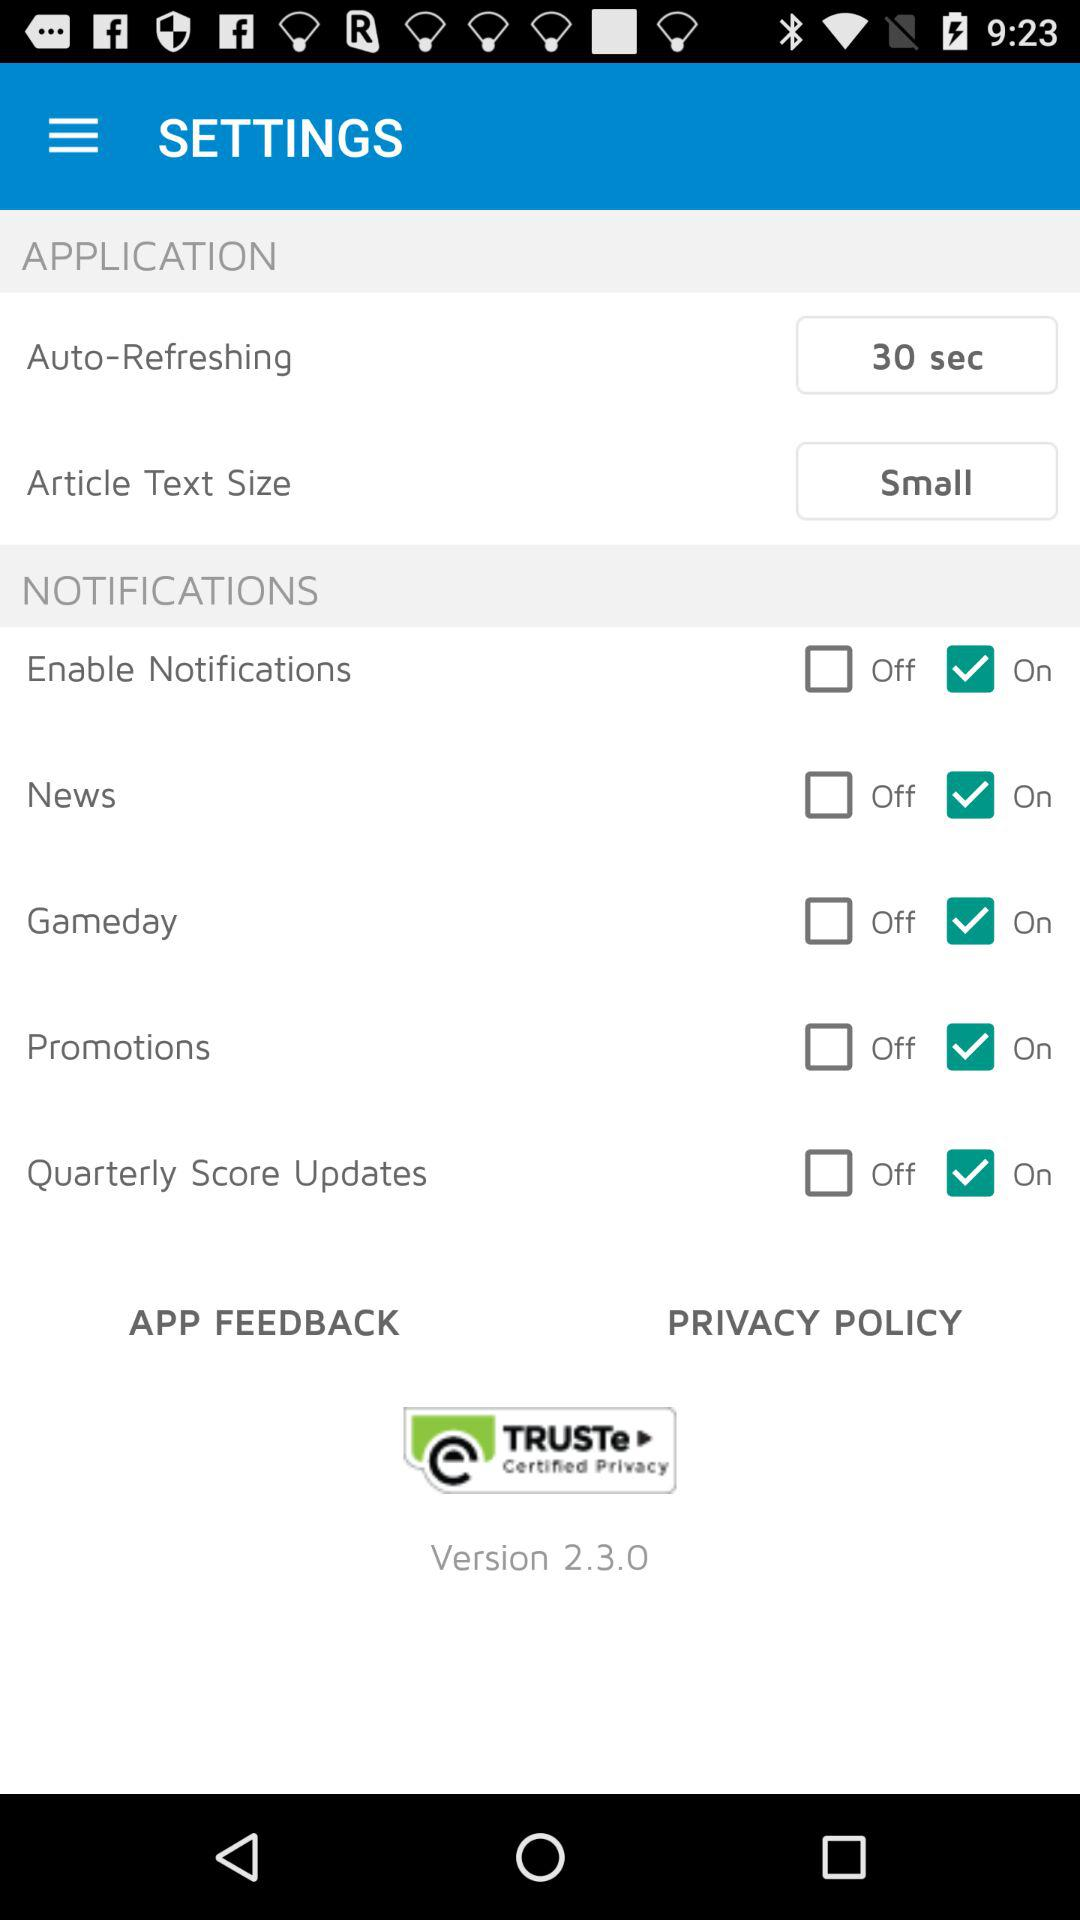What is the current status of the "Gameday"? The current status of the "Gameday" is "on". 